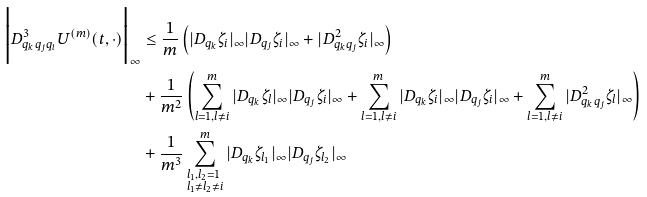Convert formula to latex. <formula><loc_0><loc_0><loc_500><loc_500>\Big { | } D ^ { 3 } _ { q _ { k } q _ { j } q _ { i } } U ^ { ( m ) } ( t , \cdot ) \Big { | } _ { \infty } & \leq \frac { 1 } { m } \left ( | D _ { q _ { k } } \zeta _ { i } | _ { \infty } | D _ { q _ { j } } \zeta _ { i } | _ { \infty } + | D ^ { 2 } _ { q _ { k } q _ { j } } \zeta _ { i } | _ { \infty } \right ) \\ & + \frac { 1 } { m ^ { 2 } } \left ( \sum _ { l = 1 , l \neq i } ^ { m } | D _ { q _ { k } } \zeta _ { l } | _ { \infty } | D _ { q _ { j } } \zeta _ { i } | _ { \infty } + \sum _ { l = 1 , l \neq i } ^ { m } | D _ { q _ { k } } \zeta _ { i } | _ { \infty } | D _ { q _ { j } } \zeta _ { i } | _ { \infty } + \sum _ { l = 1 , l \neq i } ^ { m } | D ^ { 2 } _ { q _ { k } q _ { j } } \zeta _ { l } | _ { \infty } \right ) \\ & + \frac { 1 } { m ^ { 3 } } \sum _ { \begin{subarray} { l } l _ { 1 } , l _ { 2 } = 1 \\ l _ { 1 } \neq l _ { 2 } \neq i \end{subarray} } ^ { m } | D _ { q _ { k } } \zeta _ { l _ { 1 } } | _ { \infty } | D _ { q _ { j } } \zeta _ { l _ { 2 } } | _ { \infty }</formula> 